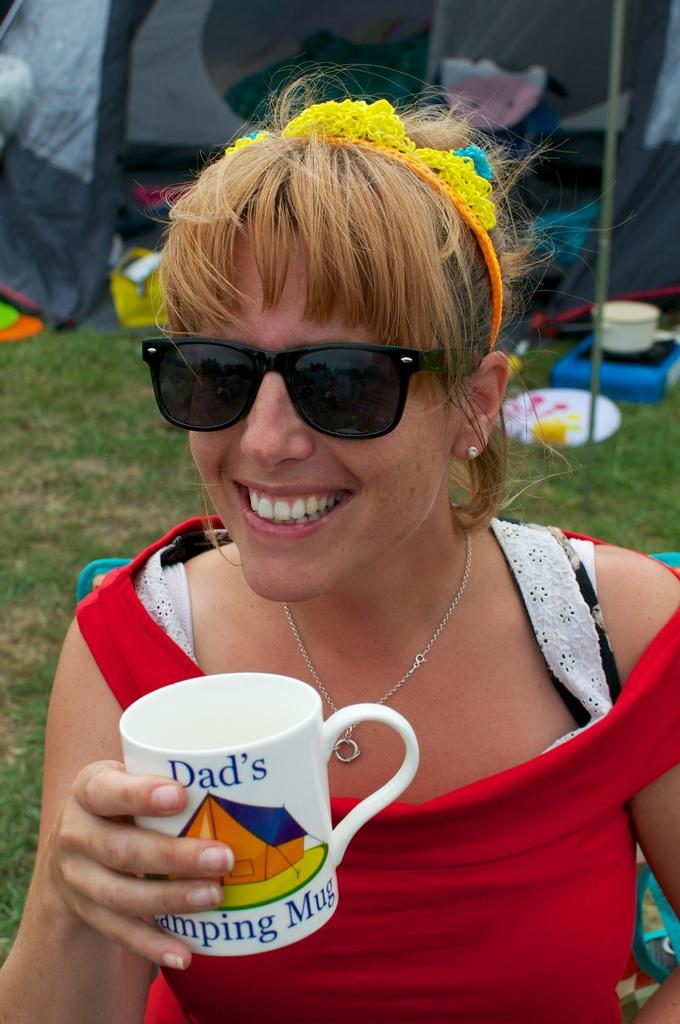What is the woman in the image wearing? The woman is wearing a red dress. What protective gear is the woman wearing? The woman is wearing goggles. What accessory is the woman wearing on her head? The woman is wearing a headband. What is the woman holding in the image? The woman is holding a cup. What can be seen in the background of the image? There is a tent, a bowl, grass, and a pole in the background of the image. What type of heart can be seen beating in the woman's wrist in the image? There is no heart or wrist visible in the image; the woman is wearing goggles and a headband, and she is holding a cup. 